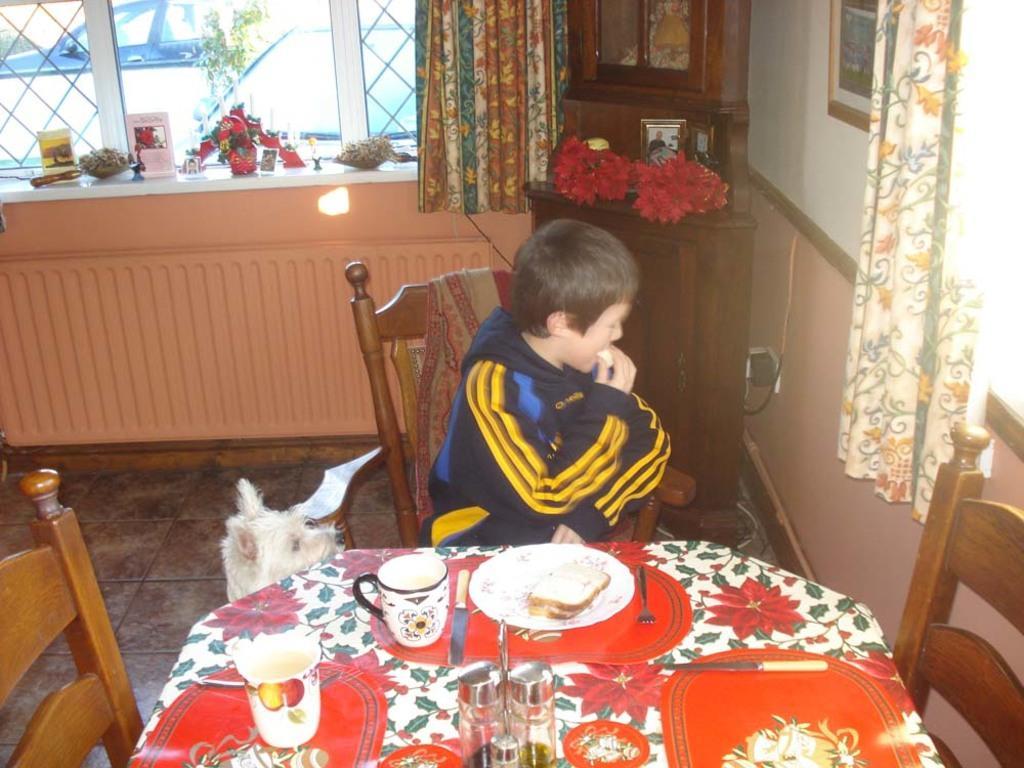Please provide a concise description of this image. A boy wearing a blue and yellow jacket is eating something and sitting on a chair. There is a dog beside him. There are another two chairs and dining table. On the dining table there is a table sheet and some knives glasses plates and bread. In the background there is a window and a small table and a flower vase , photo frame , curtains are in the background. 